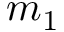Convert formula to latex. <formula><loc_0><loc_0><loc_500><loc_500>m _ { 1 }</formula> 